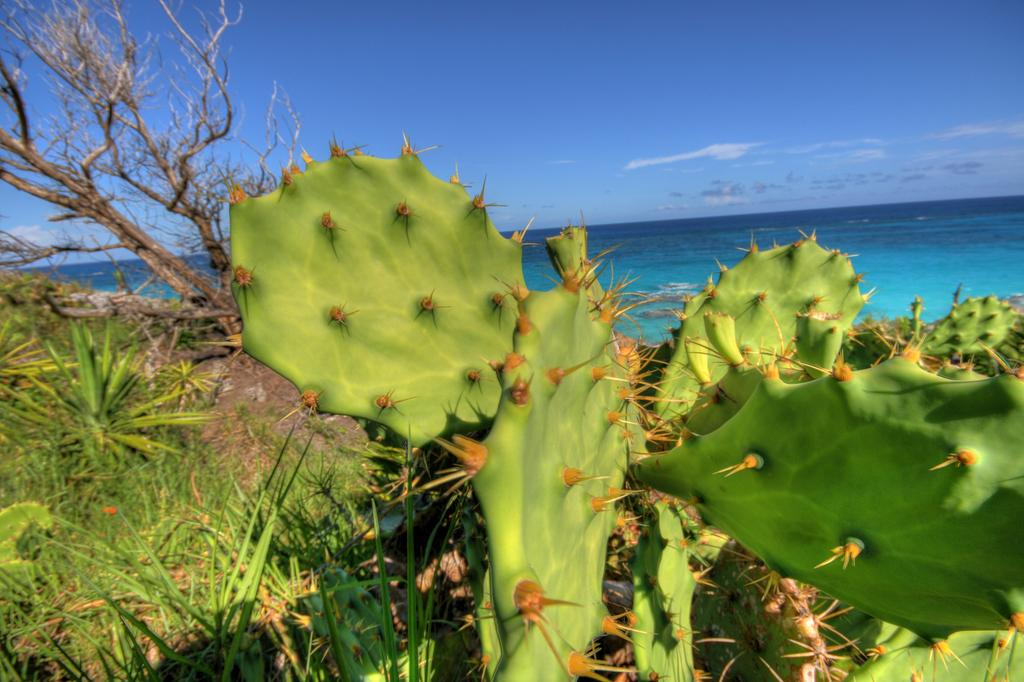What type of plant can be seen in the image? There is a cactus plant in the image. What other types of plants are present in the image? There are grass plants in the image. What is the condition of the tree in the image? There is a dried tree in the image. What is the color of the water visible in the image? The water visible in the image is blue. What is visible in the sky in the image? The sky is visible in the image, and clouds are present. What is the reaction of the cactus plant to the good-bye wave from the clouds? There is no reaction from the cactus plant, as it is a plant and cannot react to any stimuli. Additionally, there is no good-bye wave from the clouds in the image. 